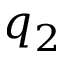Convert formula to latex. <formula><loc_0><loc_0><loc_500><loc_500>q _ { 2 }</formula> 